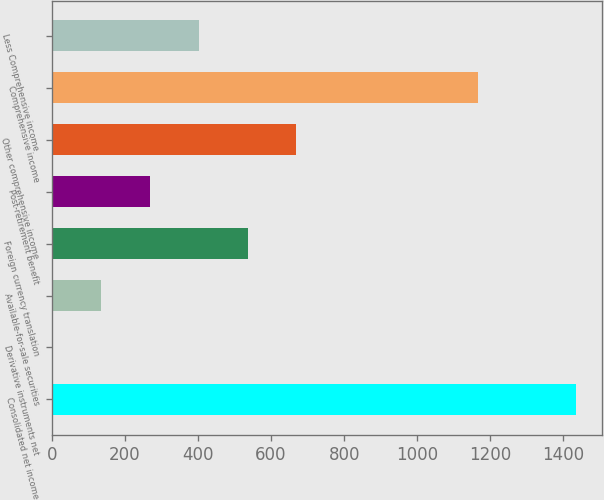Convert chart to OTSL. <chart><loc_0><loc_0><loc_500><loc_500><bar_chart><fcel>Consolidated net income<fcel>Derivative instruments net<fcel>Available-for-sale securities<fcel>Foreign currency translation<fcel>Post-retirement benefit<fcel>Other comprehensive income<fcel>Comprehensive income<fcel>Less Comprehensive income<nl><fcel>1434.4<fcel>1<fcel>134.7<fcel>535.8<fcel>268.4<fcel>669.5<fcel>1167<fcel>402.1<nl></chart> 